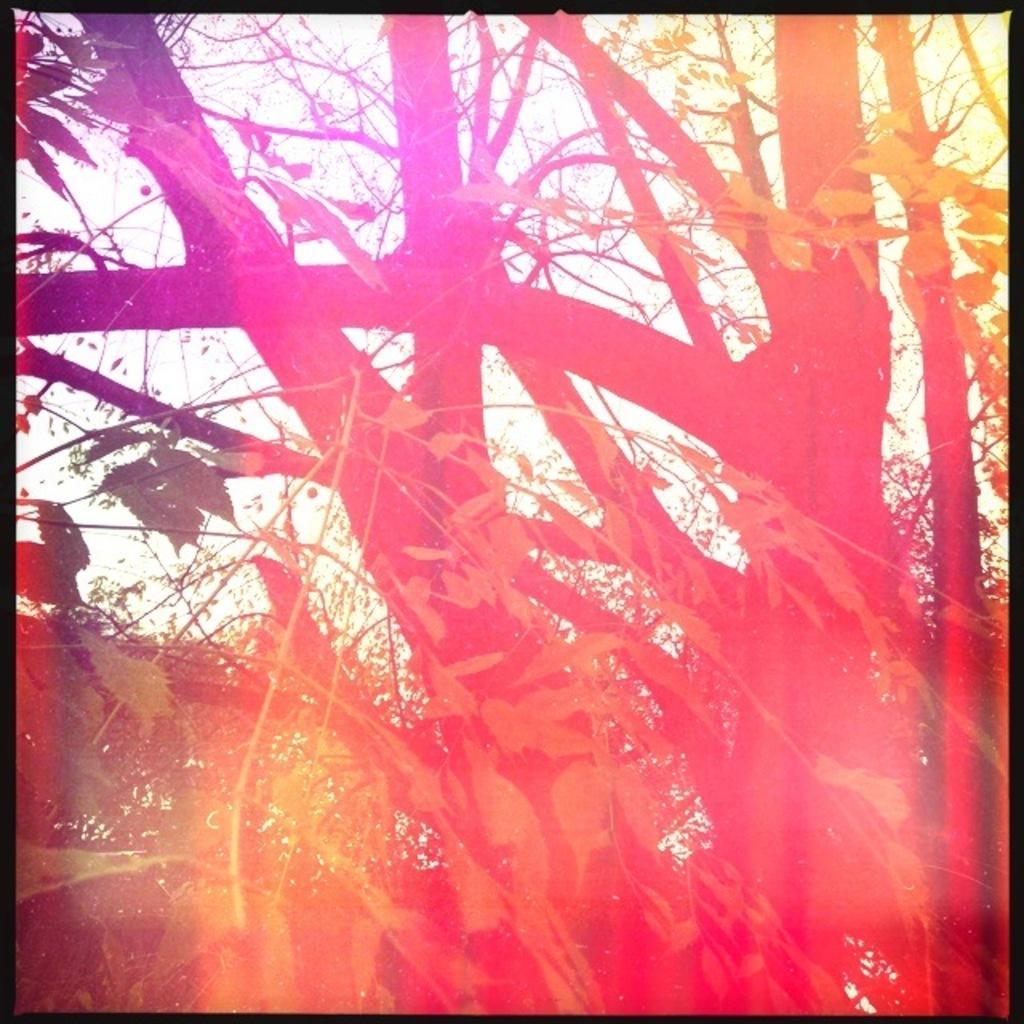How would you summarize this image in a sentence or two? In this image we can see group of trees and leaves and in the background we can see the sky. 